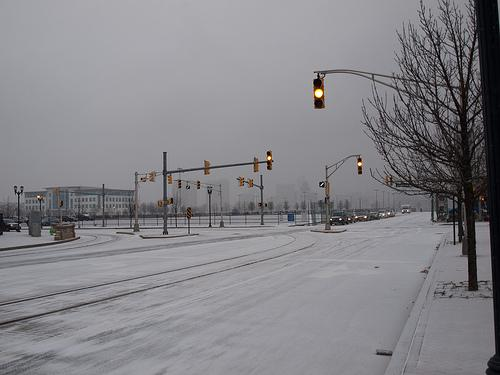Question: what is lit up?
Choices:
A. Street lights.
B. Candles.
C. Lanterns.
D. Traffic lights.
Answer with the letter. Answer: D Question: what color are the trees?
Choices:
A. Brown.
B. Red.
C. White.
D. Blue.
Answer with the letter. Answer: A Question: where are the cars?
Choices:
A. On the road.
B. By the sidewalk.
C. At stop light.
D. In the intersection.
Answer with the letter. Answer: C Question: who are holding the lights?
Choices:
A. Poles.
B. People.
C. Stakes.
D. Pillars.
Answer with the letter. Answer: A Question: why is the road dangerous?
Choices:
A. Ice.
B. Snow.
C. Narrow road.
D. Broken pavement.
Answer with the letter. Answer: B 